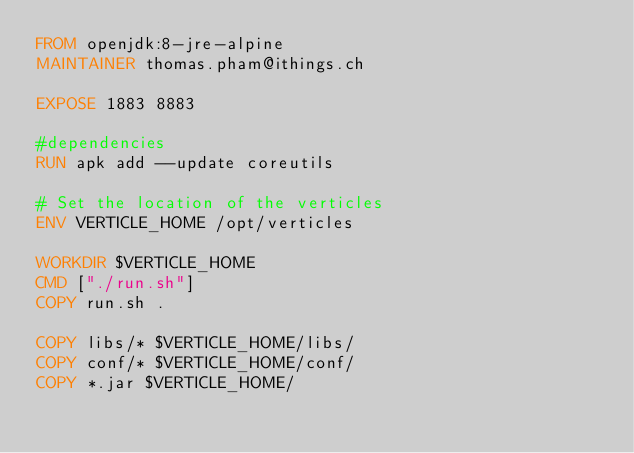<code> <loc_0><loc_0><loc_500><loc_500><_Dockerfile_>FROM openjdk:8-jre-alpine
MAINTAINER thomas.pham@ithings.ch

EXPOSE 1883 8883

#dependencies
RUN apk add --update coreutils

# Set the location of the verticles
ENV VERTICLE_HOME /opt/verticles

WORKDIR $VERTICLE_HOME
CMD ["./run.sh"]
COPY run.sh .

COPY libs/* $VERTICLE_HOME/libs/
COPY conf/* $VERTICLE_HOME/conf/
COPY *.jar $VERTICLE_HOME/
</code> 